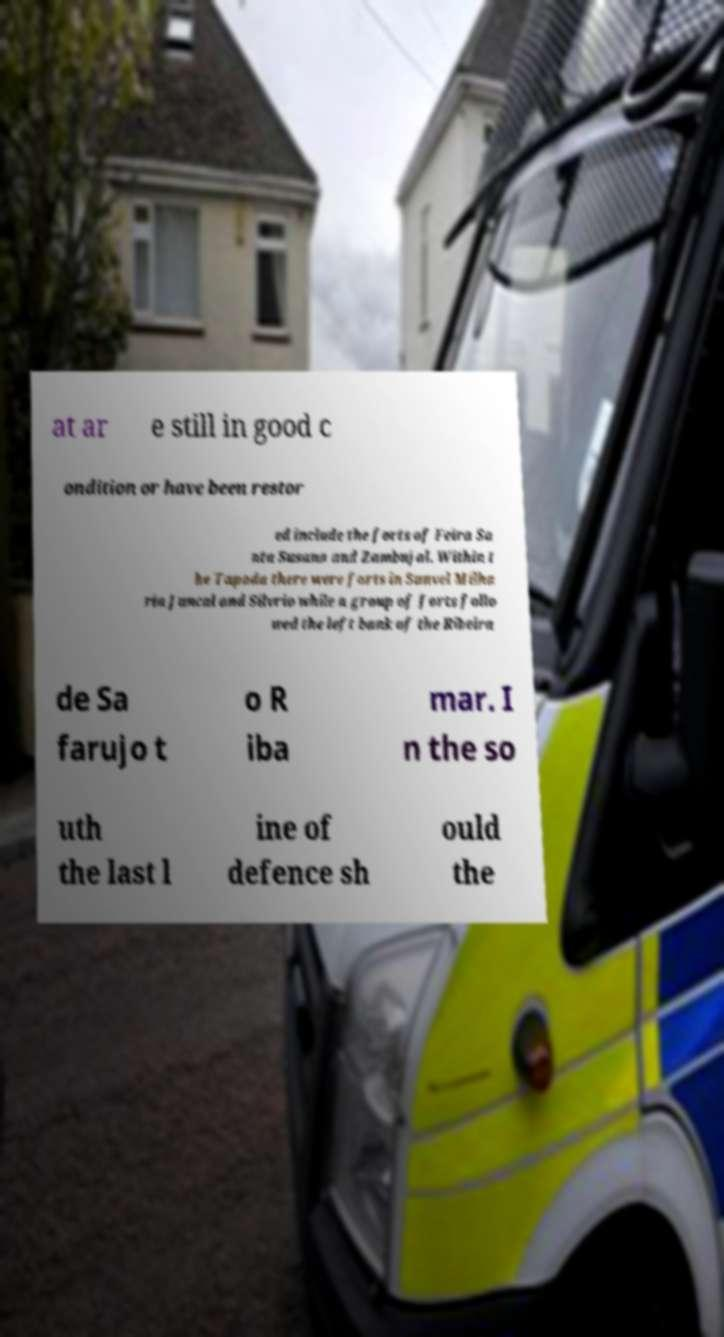I need the written content from this picture converted into text. Can you do that? at ar e still in good c ondition or have been restor ed include the forts of Feira Sa nta Susana and Zambujal. Within t he Tapada there were forts in Sunvel Milha ria Juncal and Silvrio while a group of forts follo wed the left bank of the Ribeira de Sa farujo t o R iba mar. I n the so uth the last l ine of defence sh ould the 